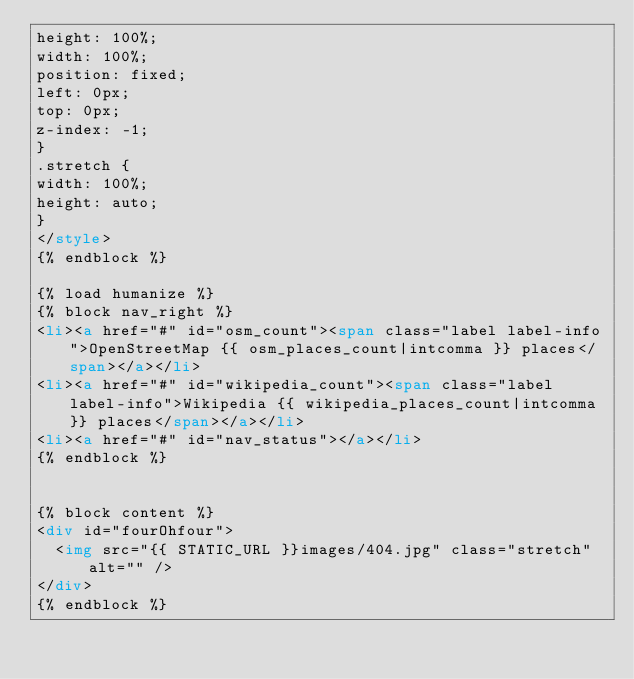<code> <loc_0><loc_0><loc_500><loc_500><_HTML_>height: 100%;
width: 100%;
position: fixed;
left: 0px;
top: 0px;
z-index: -1;
}
.stretch {
width: 100%;
height: auto;
}
</style>
{% endblock %}

{% load humanize %}
{% block nav_right %}
<li><a href="#" id="osm_count"><span class="label label-info">OpenStreetMap {{ osm_places_count|intcomma }} places</span></a></li>
<li><a href="#" id="wikipedia_count"><span class="label label-info">Wikipedia {{ wikipedia_places_count|intcomma }} places</span></a></li>
<li><a href="#" id="nav_status"></a></li>
{% endblock %}


{% block content %}
<div id="fourOhfour">
  <img src="{{ STATIC_URL }}images/404.jpg" class="stretch" alt="" />
</div>
{% endblock %}
</code> 